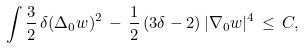<formula> <loc_0><loc_0><loc_500><loc_500>\int \frac { 3 } { 2 } \, \delta ( \Delta _ { 0 } w ) ^ { 2 } \, - \, \frac { 1 } { 2 } \, ( 3 \delta - 2 ) \, | \nabla _ { 0 } w | ^ { 4 } \, \leq \, C ,</formula> 